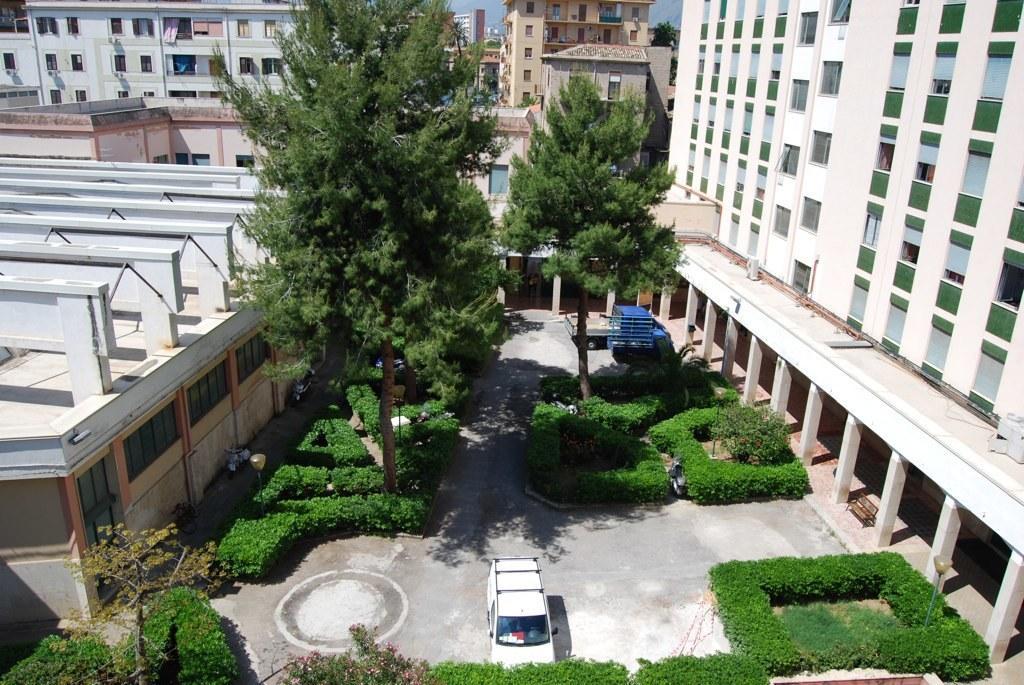Can you describe this image briefly? In the picture I can see buildings, trees, plants, vehicles on the ground and some other objects. In the background I can see the sky. 